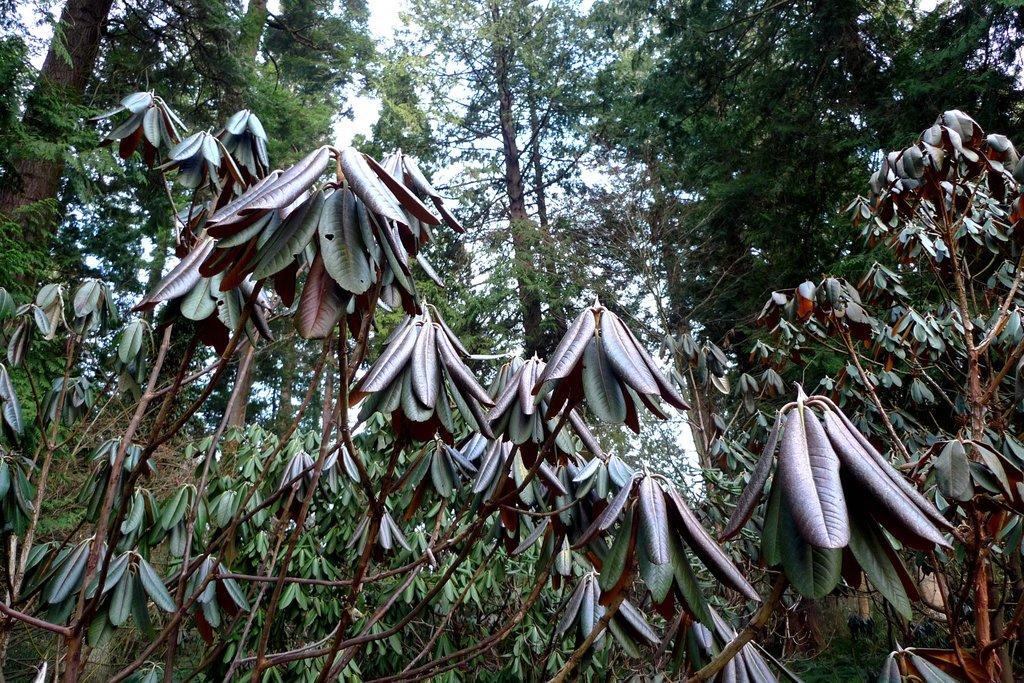Could you give a brief overview of what you see in this image? In the center of the image there are trees. In the background there is sky. 